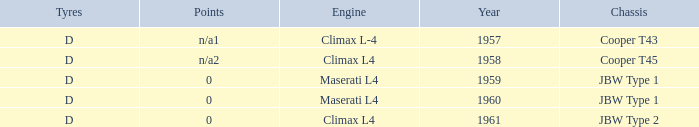What company built the chassis for a year later than 1959 and a climax l4 engine? JBW Type 2. 